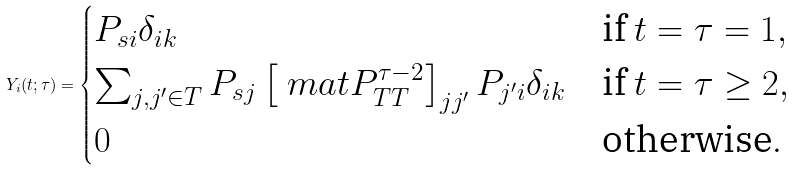<formula> <loc_0><loc_0><loc_500><loc_500>Y _ { i } ( t ; \tau ) = \begin{cases} P _ { s i } \delta _ { i k } & \text {if $t=\tau=1$} , \\ \sum _ { j , j ^ { \prime } \in T } P _ { s j } \left [ \ m a t { P } _ { T T } ^ { \tau - 2 } \right ] _ { j j ^ { \prime } } P _ { j ^ { \prime } i } \delta _ { i k } & \text {if $t=\tau\geq 2$} , \\ 0 & \text {otherwise} . \end{cases}</formula> 